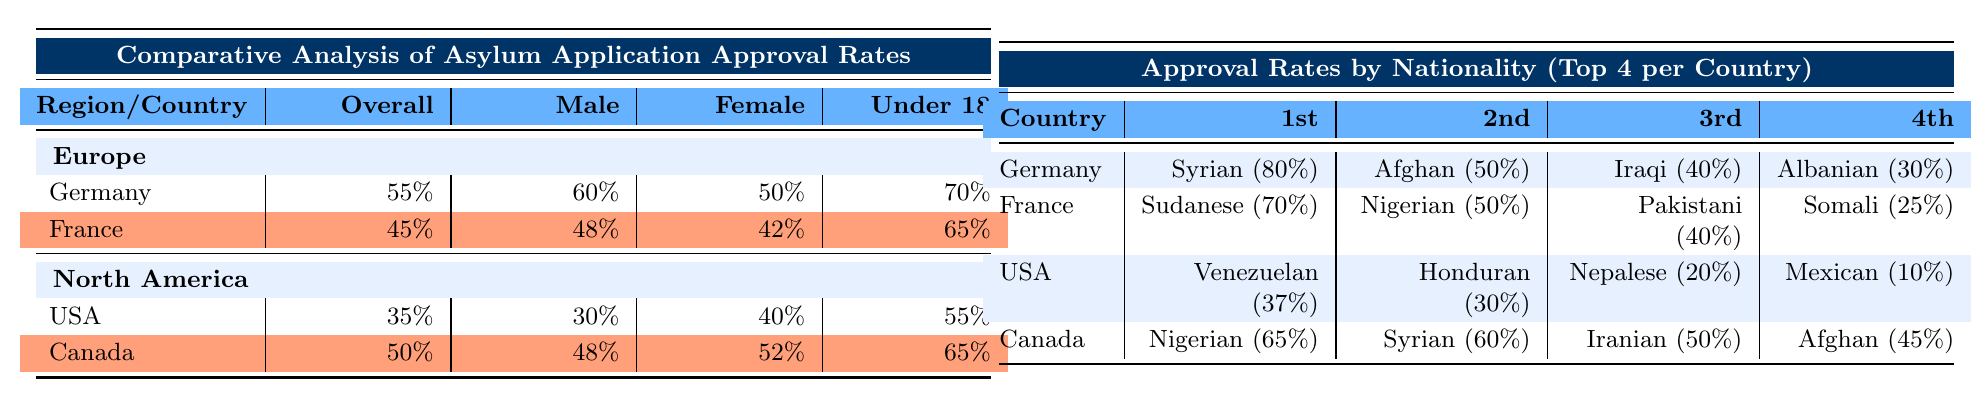What is the overall asylum application approval rate in Germany? The table shows that the approval rate for asylum applications in Germany is listed directly under "Overall" in the first row under Europe. The value is 55%.
Answer: 55% What is the approval rate for male asylum applicants in France? From the table, in the row for France, under the column for "Male," the approval rate is 48%.
Answer: 48% Which age group has the highest approval rate for asylum applications in Canada? The age groups for Canada are listed, and by looking through the row, we can see that the "Under 18" age group has the highest approval rate at 65%.
Answer: Under 18 Which nationality has the highest asylum approval rate in Germany? The table indicates that the first nationality listed under Germany is Syrian with an 80% approval rate, making it the highest.
Answer: Syrian (80%) Is the approval rate for female asylum applicants higher in Canada than in the USA? To answer this, we compare the "Female" values in their respective rows. Canada has 52% while the USA has 40%, confirming that Canada's rate is higher.
Answer: Yes What is the difference in overall approval rates between Canada and France? The overall approval rate for Canada is 50%, and for France, it is 45%. The difference can be calculated as 50% - 45% = 5%.
Answer: 5% What is the average approval rate for asylum applications by age group (Under 18) across all four countries? The approval rates for the "Under 18" group are: Germany 70%, France 65%, USA 55%, and Canada 65%. We sum these: 70 + 65 + 55 + 65 = 255, and then divide by 4 (the number of countries) to get 255 / 4 = 63.75%.
Answer: 63.75% Which countries have the lowest approval rates for asylum applicants overall? Examining the "Overall" column, we see that the USA has the lowest rate at 35%, followed by France at 45%.
Answer: USA (35%) Are male asylum applicants more likely to be approved than female asylum applicants in Germany? To determine this, we check the values under the "Male" and "Female" columns for Germany. The male approval rate is 60%, while the female rate is 50%, indicating males have a higher approval rate.
Answer: Yes What is the combined approval rate for male asylum seekers in both Germany and Canada? The "Male" approval rates are 60% for Germany and 48% for Canada. To find the combined approval rate, we add these two rates together, resulting in 60% + 48% = 108%, but since it is an average we will divide by 2 (the number of countries), resulting in a combined average of 54%.
Answer: 54% 